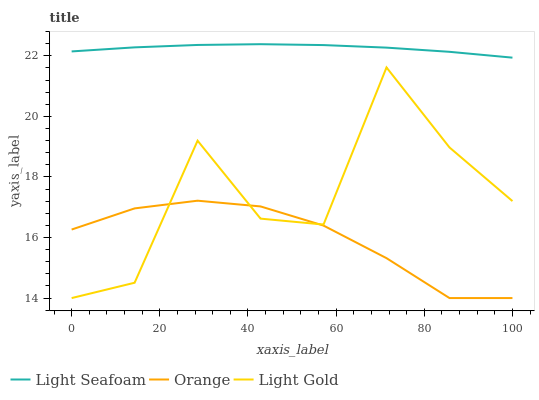Does Orange have the minimum area under the curve?
Answer yes or no. Yes. Does Light Seafoam have the maximum area under the curve?
Answer yes or no. Yes. Does Light Gold have the minimum area under the curve?
Answer yes or no. No. Does Light Gold have the maximum area under the curve?
Answer yes or no. No. Is Light Seafoam the smoothest?
Answer yes or no. Yes. Is Light Gold the roughest?
Answer yes or no. Yes. Is Light Gold the smoothest?
Answer yes or no. No. Is Light Seafoam the roughest?
Answer yes or no. No. Does Orange have the lowest value?
Answer yes or no. Yes. Does Light Seafoam have the lowest value?
Answer yes or no. No. Does Light Seafoam have the highest value?
Answer yes or no. Yes. Does Light Gold have the highest value?
Answer yes or no. No. Is Orange less than Light Seafoam?
Answer yes or no. Yes. Is Light Seafoam greater than Orange?
Answer yes or no. Yes. Does Light Gold intersect Orange?
Answer yes or no. Yes. Is Light Gold less than Orange?
Answer yes or no. No. Is Light Gold greater than Orange?
Answer yes or no. No. Does Orange intersect Light Seafoam?
Answer yes or no. No. 